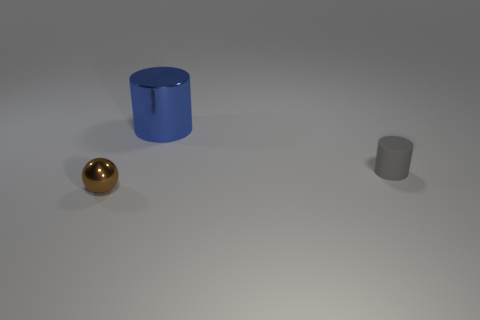Add 1 tiny brown things. How many objects exist? 4 Subtract all spheres. How many objects are left? 2 Add 2 tiny brown shiny objects. How many tiny brown shiny objects exist? 3 Subtract 0 blue cubes. How many objects are left? 3 Subtract all brown spheres. Subtract all brown spheres. How many objects are left? 1 Add 2 small cylinders. How many small cylinders are left? 3 